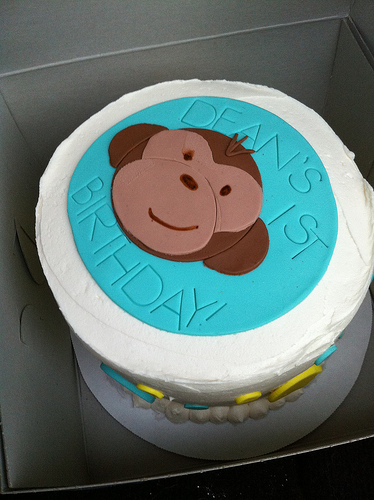<image>
Is there a monkey next to the cake? No. The monkey is not positioned next to the cake. They are located in different areas of the scene. 